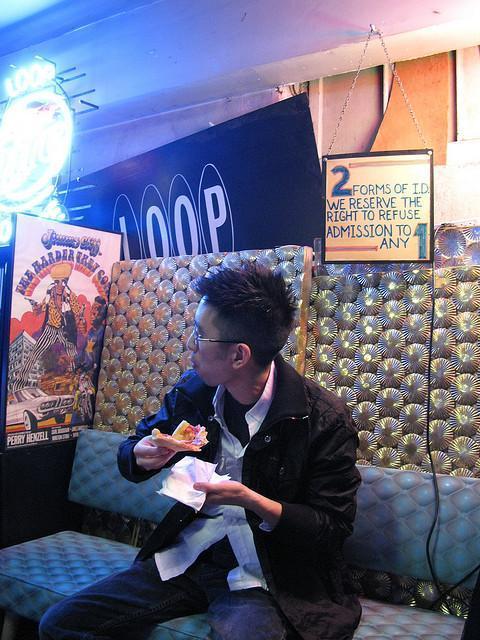How many ID's are needed at this place?
Give a very brief answer. 2. How many baby giraffes are there?
Give a very brief answer. 0. 